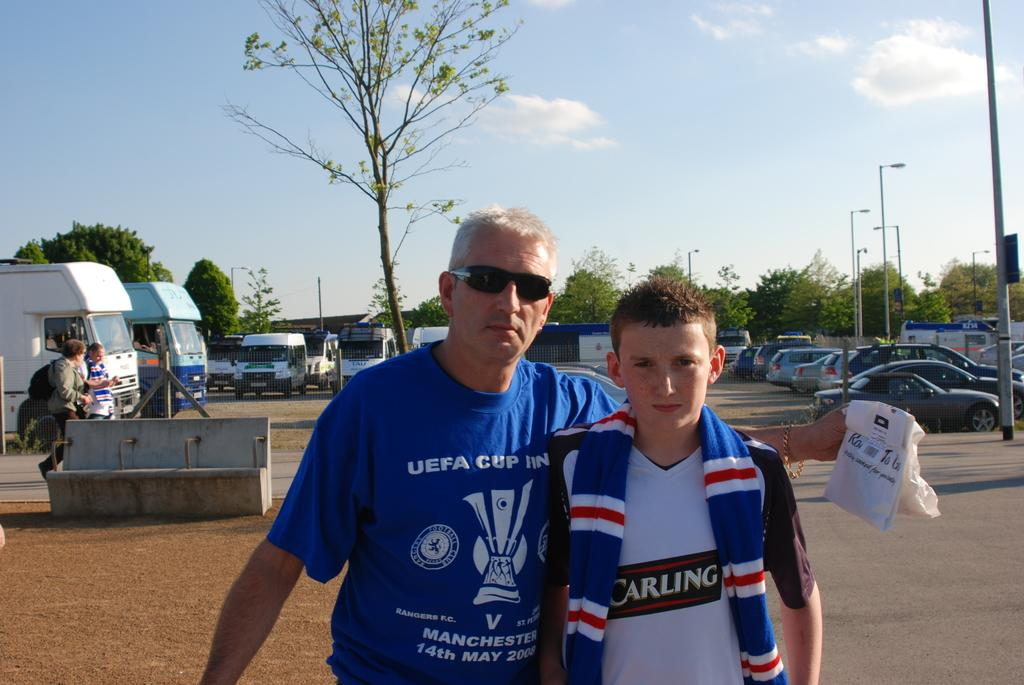Provide a one-sentence caption for the provided image. The man has a UEFA shirt on which represents the European Soccer League. 